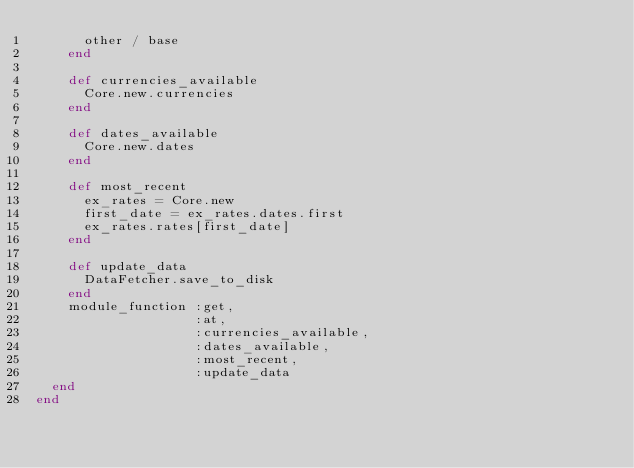<code> <loc_0><loc_0><loc_500><loc_500><_Ruby_>      other / base
    end

    def currencies_available
      Core.new.currencies
    end

    def dates_available
      Core.new.dates
    end

    def most_recent
      ex_rates = Core.new
      first_date = ex_rates.dates.first
      ex_rates.rates[first_date]
    end

    def update_data
      DataFetcher.save_to_disk
    end
    module_function :get,
                    :at,
                    :currencies_available,
                    :dates_available,
                    :most_recent,
                    :update_data
  end
end
</code> 